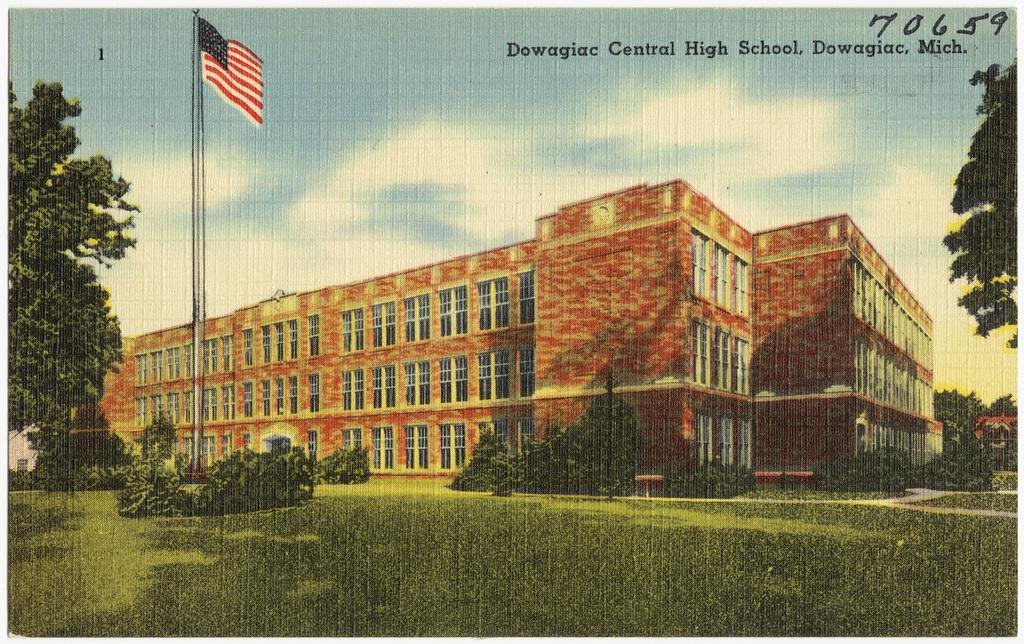What type of visual is the image? The image is a poster. What is the main subject of the poster? There is a building in the center of the image. Are there any other elements in the poster besides the building? Yes, there is a flag and trees in the image. What is the ground made of in the image? There is grass at the bottom of the image. What color are the man's trousers in the image? There is no man present in the image, so we cannot determine the color of his trousers. Is there any jelly visible in the image? There is no jelly present in the image. 